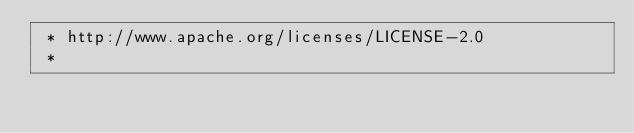Convert code to text. <code><loc_0><loc_0><loc_500><loc_500><_CSS_> * http://www.apache.org/licenses/LICENSE-2.0
 *</code> 